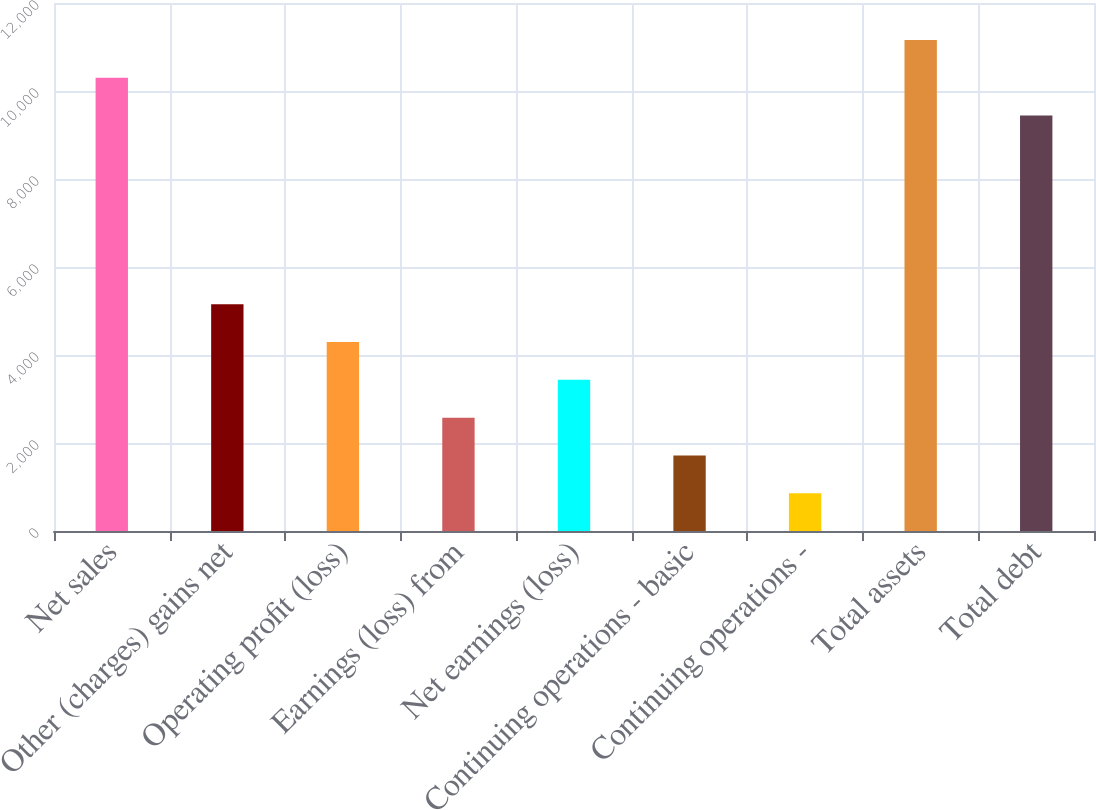Convert chart to OTSL. <chart><loc_0><loc_0><loc_500><loc_500><bar_chart><fcel>Net sales<fcel>Other (charges) gains net<fcel>Operating profit (loss)<fcel>Earnings (loss) from<fcel>Net earnings (loss)<fcel>Continuing operations - basic<fcel>Continuing operations -<fcel>Total assets<fcel>Total debt<nl><fcel>10303<fcel>5152.08<fcel>4293.59<fcel>2576.61<fcel>3435.1<fcel>1718.12<fcel>859.64<fcel>11161.5<fcel>9444.52<nl></chart> 